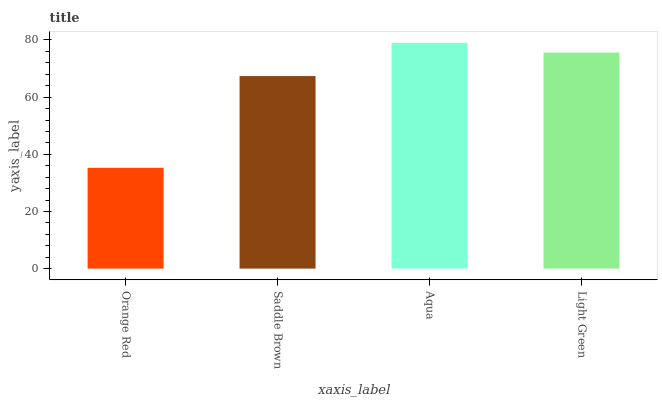Is Saddle Brown the minimum?
Answer yes or no. No. Is Saddle Brown the maximum?
Answer yes or no. No. Is Saddle Brown greater than Orange Red?
Answer yes or no. Yes. Is Orange Red less than Saddle Brown?
Answer yes or no. Yes. Is Orange Red greater than Saddle Brown?
Answer yes or no. No. Is Saddle Brown less than Orange Red?
Answer yes or no. No. Is Light Green the high median?
Answer yes or no. Yes. Is Saddle Brown the low median?
Answer yes or no. Yes. Is Orange Red the high median?
Answer yes or no. No. Is Orange Red the low median?
Answer yes or no. No. 